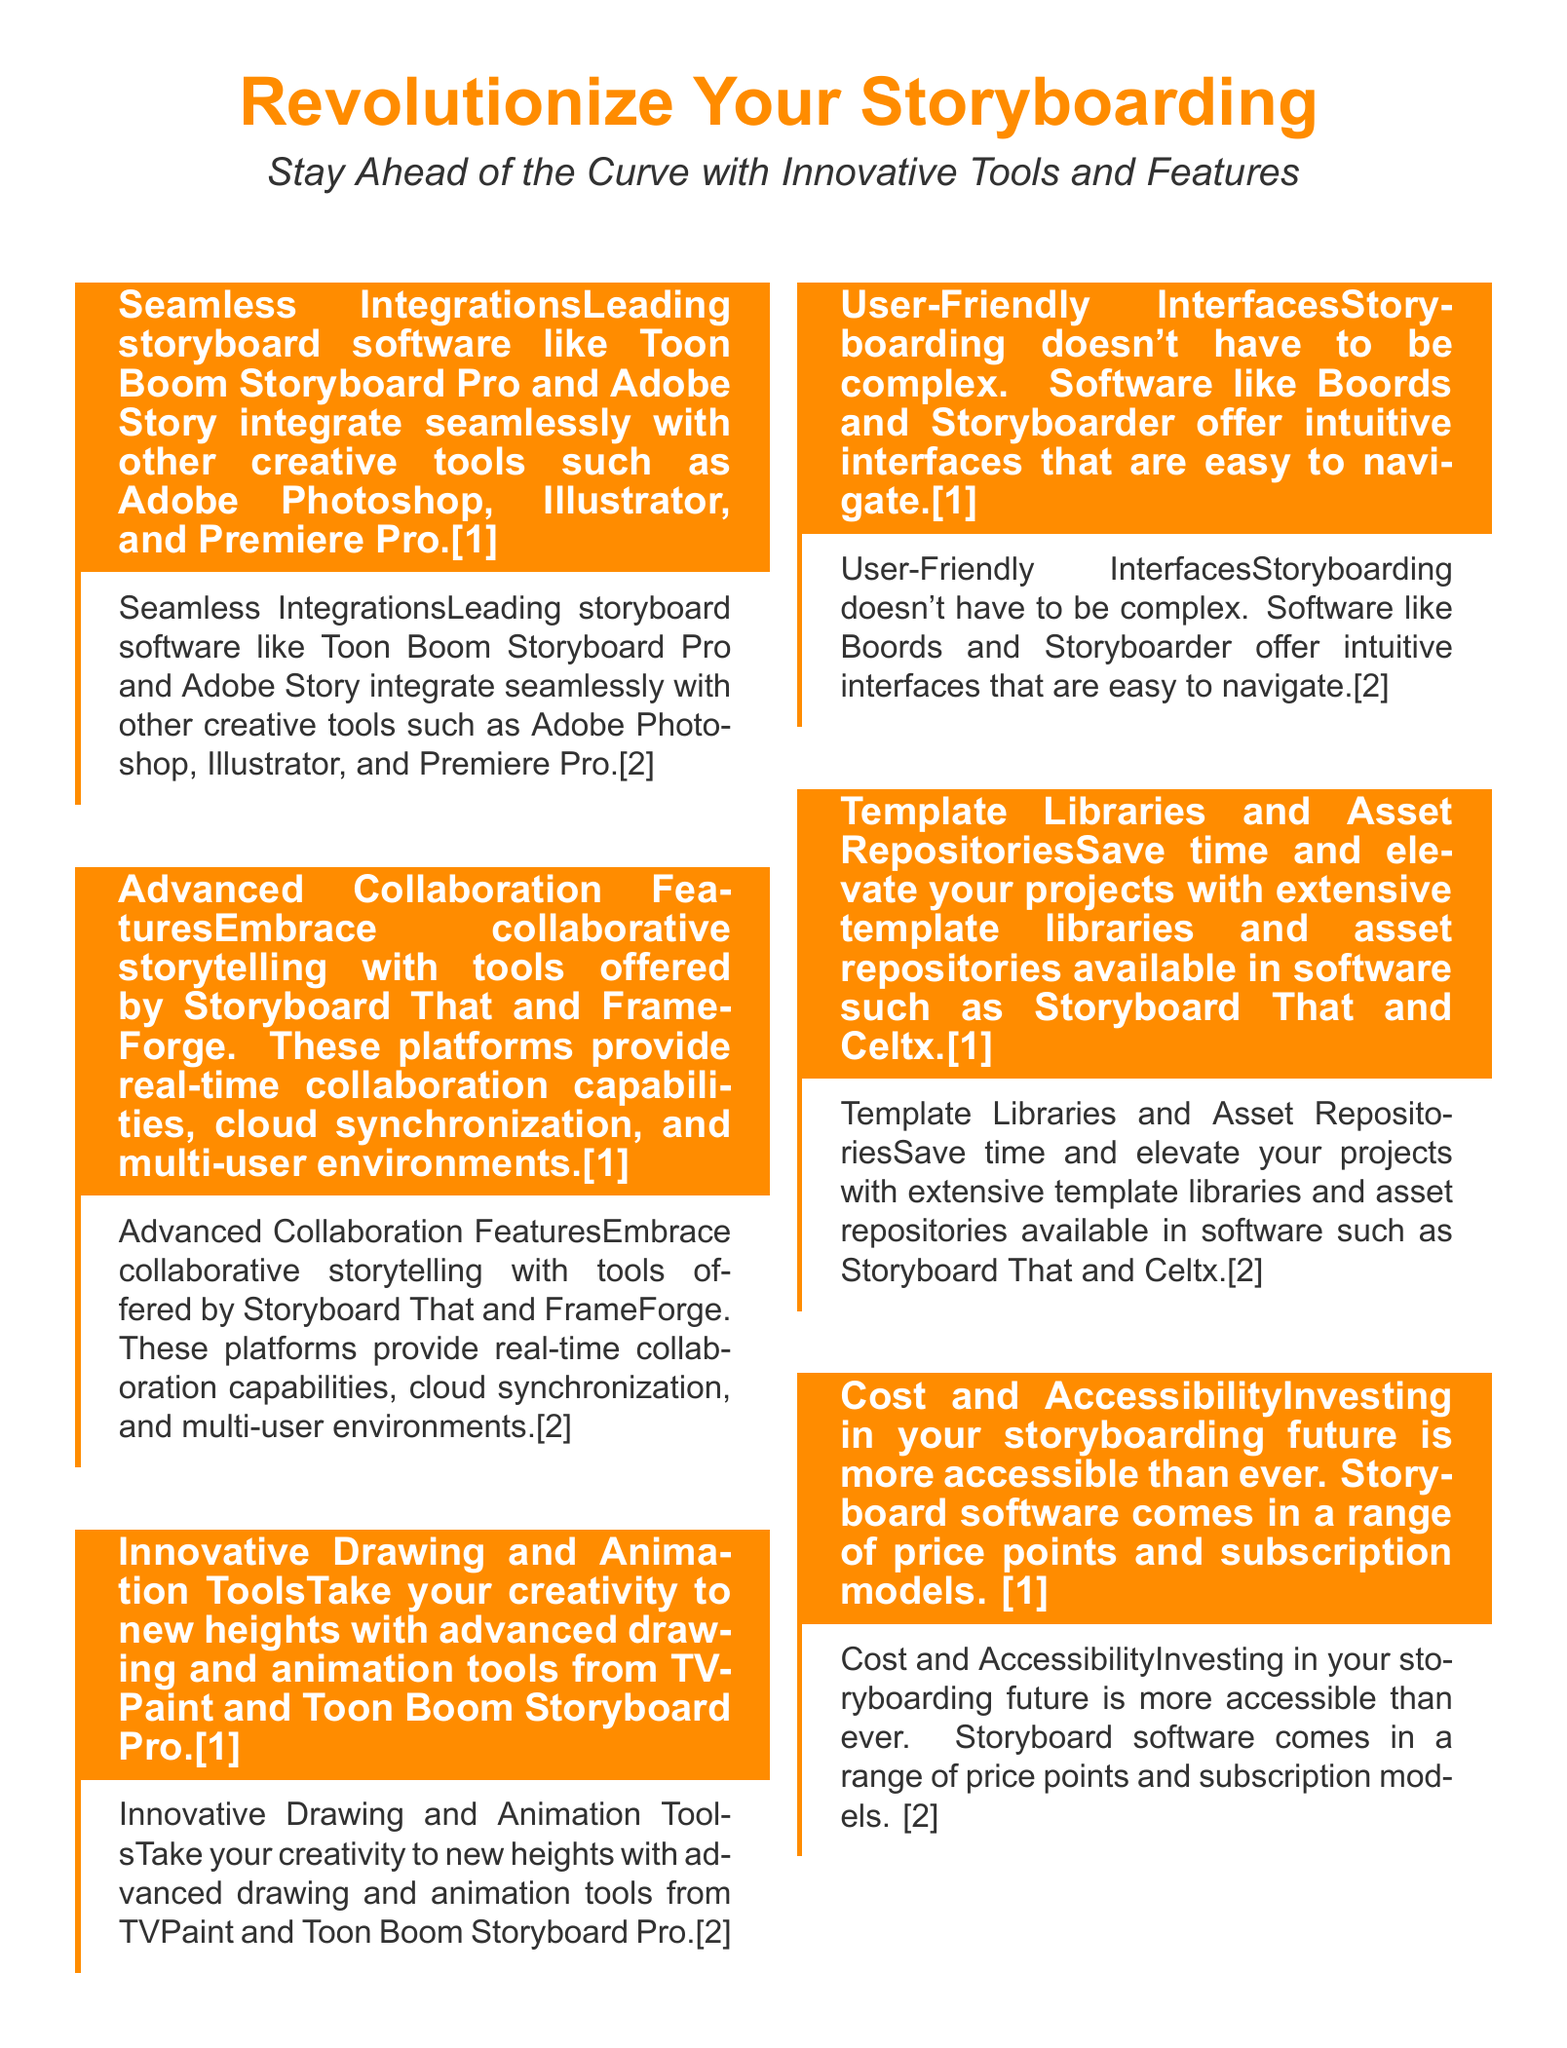What is the main focus of the advertisement? The main focus of the advertisement is about revolutionizing storyboarding with innovative tools and features.
Answer: Revolutionize Your Storyboarding Which software integrates seamlessly with Adobe tools? The software that integrates seamlessly with Adobe tools is Toon Boom Storyboard Pro and Adobe Story.
Answer: Toon Boom Storyboard Pro and Adobe Story What collaboration features do Storyboard That and FrameForge offer? Storyboard That and FrameForge offer real-time collaboration capabilities, cloud synchronization, and multi-user environments.
Answer: Real-time collaboration capabilities Which software is known for user-friendly interfaces? The software known for user-friendly interfaces includes Boords and Storyboarder.
Answer: Boords and Storyboarder What type of libraries does Storyboard That provide? Storyboard That provides extensive template libraries and asset repositories.
Answer: Template libraries and asset repositories What is the aim of the final box statement? The aim of the final box statement is to encourage readers to equip themselves with the best storyboard software.
Answer: Equip yourself with the best storyboard software What color is used for the title text in the tcolorbox? The color used for the title text in the tcolorbox is white.
Answer: White How many main sections are highlighted in the advertisement? The advertisement highlights six main sections.
Answer: Six What aspect of storyboarding is emphasized for cost accessibility? The advertisement emphasizes a range of price points and subscription models for cost accessibility.
Answer: Range of price points and subscription models 